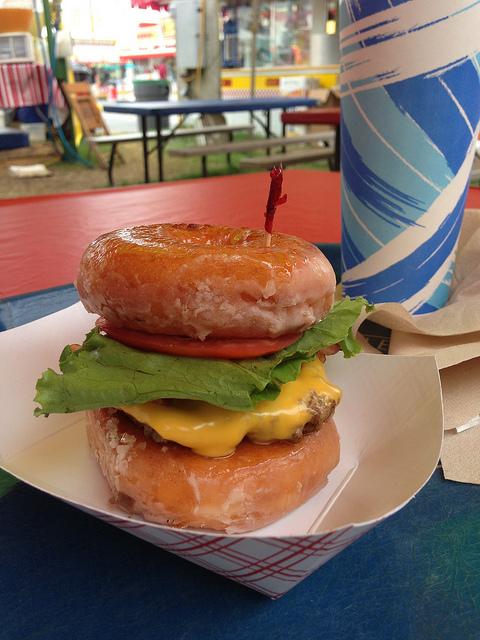What is holding the sandwich together?
Keep it brief. Toothpick. What color is the cheese on the sandwich?
Be succinct. Yellow. Is it night time?
Concise answer only. No. Is there a drink?
Write a very short answer. Yes. 